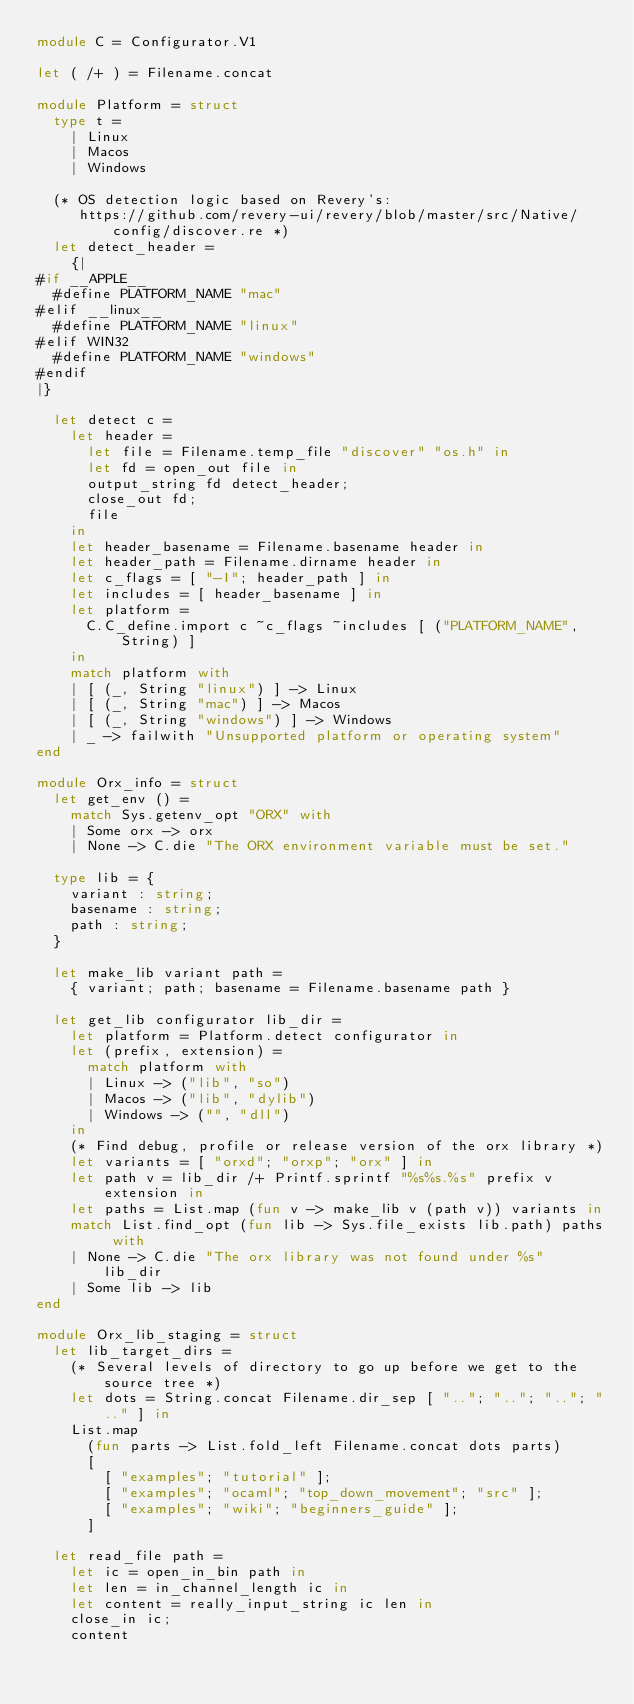<code> <loc_0><loc_0><loc_500><loc_500><_OCaml_>module C = Configurator.V1

let ( /+ ) = Filename.concat

module Platform = struct
  type t =
    | Linux
    | Macos
    | Windows

  (* OS detection logic based on Revery's:
     https://github.com/revery-ui/revery/blob/master/src/Native/config/discover.re *)
  let detect_header =
    {|
#if __APPLE__
  #define PLATFORM_NAME "mac"
#elif __linux__
  #define PLATFORM_NAME "linux"
#elif WIN32
  #define PLATFORM_NAME "windows"
#endif
|}

  let detect c =
    let header =
      let file = Filename.temp_file "discover" "os.h" in
      let fd = open_out file in
      output_string fd detect_header;
      close_out fd;
      file
    in
    let header_basename = Filename.basename header in
    let header_path = Filename.dirname header in
    let c_flags = [ "-I"; header_path ] in
    let includes = [ header_basename ] in
    let platform =
      C.C_define.import c ~c_flags ~includes [ ("PLATFORM_NAME", String) ]
    in
    match platform with
    | [ (_, String "linux") ] -> Linux
    | [ (_, String "mac") ] -> Macos
    | [ (_, String "windows") ] -> Windows
    | _ -> failwith "Unsupported platform or operating system"
end

module Orx_info = struct
  let get_env () =
    match Sys.getenv_opt "ORX" with
    | Some orx -> orx
    | None -> C.die "The ORX environment variable must be set."

  type lib = {
    variant : string;
    basename : string;
    path : string;
  }

  let make_lib variant path =
    { variant; path; basename = Filename.basename path }

  let get_lib configurator lib_dir =
    let platform = Platform.detect configurator in
    let (prefix, extension) =
      match platform with
      | Linux -> ("lib", "so")
      | Macos -> ("lib", "dylib")
      | Windows -> ("", "dll")
    in
    (* Find debug, profile or release version of the orx library *)
    let variants = [ "orxd"; "orxp"; "orx" ] in
    let path v = lib_dir /+ Printf.sprintf "%s%s.%s" prefix v extension in
    let paths = List.map (fun v -> make_lib v (path v)) variants in
    match List.find_opt (fun lib -> Sys.file_exists lib.path) paths with
    | None -> C.die "The orx library was not found under %s" lib_dir
    | Some lib -> lib
end

module Orx_lib_staging = struct
  let lib_target_dirs =
    (* Several levels of directory to go up before we get to the source tree *)
    let dots = String.concat Filename.dir_sep [ ".."; ".."; ".."; ".." ] in
    List.map
      (fun parts -> List.fold_left Filename.concat dots parts)
      [
        [ "examples"; "tutorial" ];
        [ "examples"; "ocaml"; "top_down_movement"; "src" ];
        [ "examples"; "wiki"; "beginners_guide" ];
      ]

  let read_file path =
    let ic = open_in_bin path in
    let len = in_channel_length ic in
    let content = really_input_string ic len in
    close_in ic;
    content
</code> 